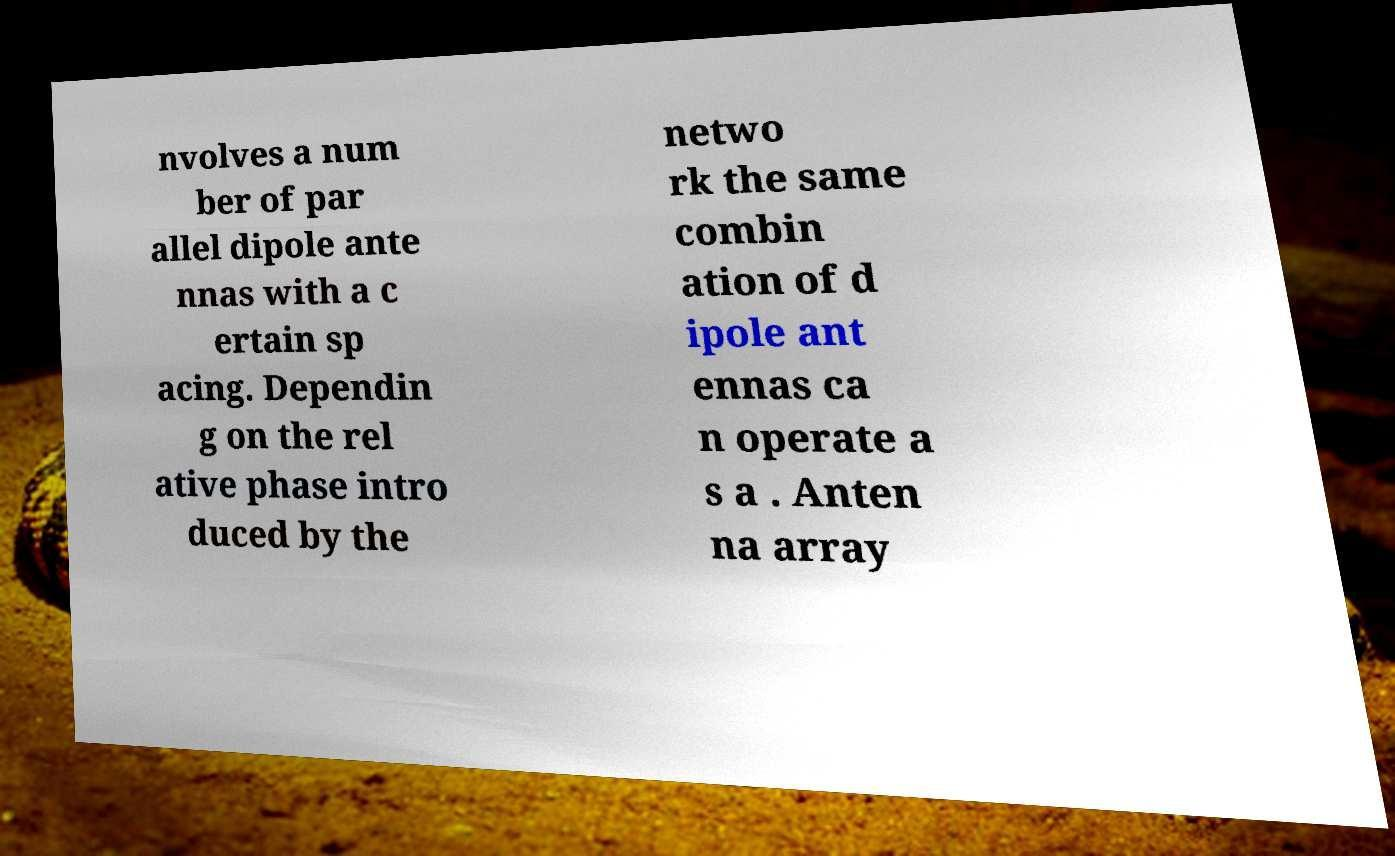What messages or text are displayed in this image? I need them in a readable, typed format. nvolves a num ber of par allel dipole ante nnas with a c ertain sp acing. Dependin g on the rel ative phase intro duced by the netwo rk the same combin ation of d ipole ant ennas ca n operate a s a . Anten na array 